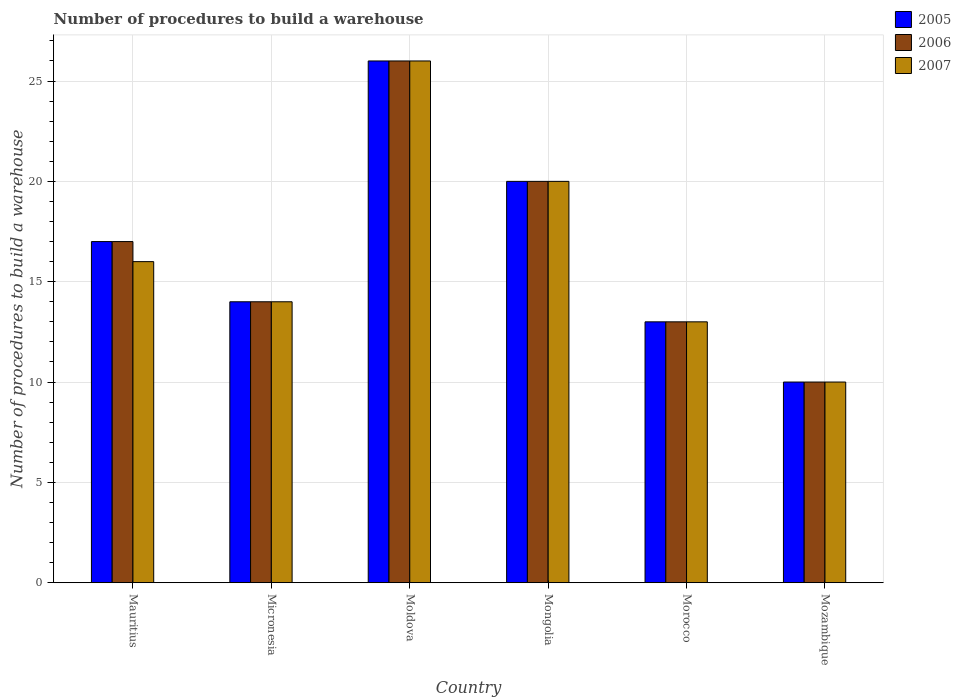How many bars are there on the 6th tick from the right?
Keep it short and to the point. 3. What is the label of the 5th group of bars from the left?
Provide a succinct answer. Morocco. In how many cases, is the number of bars for a given country not equal to the number of legend labels?
Offer a very short reply. 0. Across all countries, what is the maximum number of procedures to build a warehouse in in 2005?
Provide a succinct answer. 26. Across all countries, what is the minimum number of procedures to build a warehouse in in 2005?
Offer a terse response. 10. In which country was the number of procedures to build a warehouse in in 2007 maximum?
Offer a terse response. Moldova. In which country was the number of procedures to build a warehouse in in 2007 minimum?
Your answer should be compact. Mozambique. What is the total number of procedures to build a warehouse in in 2007 in the graph?
Your response must be concise. 99. What is the difference between the number of procedures to build a warehouse in in 2006 in Mongolia and the number of procedures to build a warehouse in in 2007 in Moldova?
Offer a very short reply. -6. What is the average number of procedures to build a warehouse in in 2005 per country?
Your answer should be very brief. 16.67. What is the difference between the number of procedures to build a warehouse in of/in 2007 and number of procedures to build a warehouse in of/in 2005 in Mozambique?
Offer a very short reply. 0. What is the ratio of the number of procedures to build a warehouse in in 2007 in Mauritius to that in Micronesia?
Keep it short and to the point. 1.14. Is the number of procedures to build a warehouse in in 2005 in Micronesia less than that in Mongolia?
Give a very brief answer. Yes. Is the difference between the number of procedures to build a warehouse in in 2007 in Mongolia and Mozambique greater than the difference between the number of procedures to build a warehouse in in 2005 in Mongolia and Mozambique?
Your answer should be compact. No. What is the difference between the highest and the second highest number of procedures to build a warehouse in in 2005?
Give a very brief answer. -9. In how many countries, is the number of procedures to build a warehouse in in 2007 greater than the average number of procedures to build a warehouse in in 2007 taken over all countries?
Offer a very short reply. 2. Is the sum of the number of procedures to build a warehouse in in 2007 in Micronesia and Mongolia greater than the maximum number of procedures to build a warehouse in in 2005 across all countries?
Your answer should be compact. Yes. What does the 1st bar from the left in Mongolia represents?
Your response must be concise. 2005. What does the 2nd bar from the right in Moldova represents?
Keep it short and to the point. 2006. How many bars are there?
Your response must be concise. 18. What is the difference between two consecutive major ticks on the Y-axis?
Ensure brevity in your answer.  5. Are the values on the major ticks of Y-axis written in scientific E-notation?
Your response must be concise. No. Where does the legend appear in the graph?
Offer a terse response. Top right. How many legend labels are there?
Give a very brief answer. 3. What is the title of the graph?
Ensure brevity in your answer.  Number of procedures to build a warehouse. What is the label or title of the X-axis?
Keep it short and to the point. Country. What is the label or title of the Y-axis?
Make the answer very short. Number of procedures to build a warehouse. What is the Number of procedures to build a warehouse in 2005 in Mauritius?
Your answer should be compact. 17. What is the Number of procedures to build a warehouse of 2007 in Mauritius?
Provide a succinct answer. 16. What is the Number of procedures to build a warehouse of 2006 in Moldova?
Your response must be concise. 26. What is the Number of procedures to build a warehouse of 2007 in Moldova?
Your answer should be very brief. 26. What is the Number of procedures to build a warehouse of 2005 in Mongolia?
Your answer should be very brief. 20. What is the Number of procedures to build a warehouse in 2007 in Mongolia?
Provide a short and direct response. 20. What is the Number of procedures to build a warehouse of 2005 in Morocco?
Keep it short and to the point. 13. What is the Number of procedures to build a warehouse in 2007 in Mozambique?
Your answer should be compact. 10. Across all countries, what is the maximum Number of procedures to build a warehouse in 2005?
Your answer should be very brief. 26. Across all countries, what is the minimum Number of procedures to build a warehouse in 2007?
Your response must be concise. 10. What is the total Number of procedures to build a warehouse of 2007 in the graph?
Your answer should be very brief. 99. What is the difference between the Number of procedures to build a warehouse of 2007 in Mauritius and that in Micronesia?
Your answer should be compact. 2. What is the difference between the Number of procedures to build a warehouse in 2006 in Mauritius and that in Moldova?
Offer a terse response. -9. What is the difference between the Number of procedures to build a warehouse in 2007 in Mauritius and that in Moldova?
Provide a succinct answer. -10. What is the difference between the Number of procedures to build a warehouse of 2007 in Mauritius and that in Mongolia?
Offer a terse response. -4. What is the difference between the Number of procedures to build a warehouse in 2006 in Mauritius and that in Morocco?
Your response must be concise. 4. What is the difference between the Number of procedures to build a warehouse of 2007 in Mauritius and that in Morocco?
Give a very brief answer. 3. What is the difference between the Number of procedures to build a warehouse in 2005 in Mauritius and that in Mozambique?
Give a very brief answer. 7. What is the difference between the Number of procedures to build a warehouse of 2006 in Mauritius and that in Mozambique?
Provide a succinct answer. 7. What is the difference between the Number of procedures to build a warehouse of 2007 in Mauritius and that in Mozambique?
Provide a succinct answer. 6. What is the difference between the Number of procedures to build a warehouse of 2005 in Micronesia and that in Moldova?
Give a very brief answer. -12. What is the difference between the Number of procedures to build a warehouse of 2007 in Micronesia and that in Moldova?
Give a very brief answer. -12. What is the difference between the Number of procedures to build a warehouse in 2005 in Micronesia and that in Mongolia?
Provide a succinct answer. -6. What is the difference between the Number of procedures to build a warehouse in 2006 in Micronesia and that in Morocco?
Ensure brevity in your answer.  1. What is the difference between the Number of procedures to build a warehouse of 2005 in Micronesia and that in Mozambique?
Make the answer very short. 4. What is the difference between the Number of procedures to build a warehouse of 2006 in Micronesia and that in Mozambique?
Provide a short and direct response. 4. What is the difference between the Number of procedures to build a warehouse of 2007 in Micronesia and that in Mozambique?
Offer a very short reply. 4. What is the difference between the Number of procedures to build a warehouse of 2005 in Moldova and that in Mongolia?
Your answer should be very brief. 6. What is the difference between the Number of procedures to build a warehouse of 2007 in Moldova and that in Mongolia?
Your answer should be compact. 6. What is the difference between the Number of procedures to build a warehouse in 2005 in Moldova and that in Mozambique?
Ensure brevity in your answer.  16. What is the difference between the Number of procedures to build a warehouse in 2006 in Moldova and that in Mozambique?
Your response must be concise. 16. What is the difference between the Number of procedures to build a warehouse in 2007 in Moldova and that in Mozambique?
Provide a short and direct response. 16. What is the difference between the Number of procedures to build a warehouse in 2007 in Mongolia and that in Morocco?
Provide a short and direct response. 7. What is the difference between the Number of procedures to build a warehouse in 2005 in Mongolia and that in Mozambique?
Make the answer very short. 10. What is the difference between the Number of procedures to build a warehouse of 2006 in Mongolia and that in Mozambique?
Give a very brief answer. 10. What is the difference between the Number of procedures to build a warehouse of 2007 in Mongolia and that in Mozambique?
Your answer should be very brief. 10. What is the difference between the Number of procedures to build a warehouse in 2006 in Morocco and that in Mozambique?
Your response must be concise. 3. What is the difference between the Number of procedures to build a warehouse in 2005 in Mauritius and the Number of procedures to build a warehouse in 2006 in Micronesia?
Ensure brevity in your answer.  3. What is the difference between the Number of procedures to build a warehouse in 2005 in Mauritius and the Number of procedures to build a warehouse in 2007 in Moldova?
Provide a short and direct response. -9. What is the difference between the Number of procedures to build a warehouse of 2006 in Mauritius and the Number of procedures to build a warehouse of 2007 in Moldova?
Offer a very short reply. -9. What is the difference between the Number of procedures to build a warehouse of 2005 in Mauritius and the Number of procedures to build a warehouse of 2006 in Mongolia?
Your answer should be very brief. -3. What is the difference between the Number of procedures to build a warehouse in 2005 in Mauritius and the Number of procedures to build a warehouse in 2007 in Mongolia?
Your response must be concise. -3. What is the difference between the Number of procedures to build a warehouse in 2006 in Mauritius and the Number of procedures to build a warehouse in 2007 in Mongolia?
Your response must be concise. -3. What is the difference between the Number of procedures to build a warehouse of 2005 in Mauritius and the Number of procedures to build a warehouse of 2007 in Mozambique?
Keep it short and to the point. 7. What is the difference between the Number of procedures to build a warehouse of 2006 in Mauritius and the Number of procedures to build a warehouse of 2007 in Mozambique?
Your response must be concise. 7. What is the difference between the Number of procedures to build a warehouse in 2005 in Micronesia and the Number of procedures to build a warehouse in 2006 in Moldova?
Your answer should be compact. -12. What is the difference between the Number of procedures to build a warehouse in 2005 in Micronesia and the Number of procedures to build a warehouse in 2007 in Moldova?
Ensure brevity in your answer.  -12. What is the difference between the Number of procedures to build a warehouse of 2005 in Micronesia and the Number of procedures to build a warehouse of 2007 in Mongolia?
Offer a terse response. -6. What is the difference between the Number of procedures to build a warehouse of 2006 in Micronesia and the Number of procedures to build a warehouse of 2007 in Mongolia?
Your answer should be very brief. -6. What is the difference between the Number of procedures to build a warehouse of 2005 in Micronesia and the Number of procedures to build a warehouse of 2007 in Morocco?
Ensure brevity in your answer.  1. What is the difference between the Number of procedures to build a warehouse of 2006 in Micronesia and the Number of procedures to build a warehouse of 2007 in Morocco?
Ensure brevity in your answer.  1. What is the difference between the Number of procedures to build a warehouse of 2005 in Micronesia and the Number of procedures to build a warehouse of 2006 in Mozambique?
Keep it short and to the point. 4. What is the difference between the Number of procedures to build a warehouse of 2005 in Micronesia and the Number of procedures to build a warehouse of 2007 in Mozambique?
Your answer should be compact. 4. What is the difference between the Number of procedures to build a warehouse in 2006 in Moldova and the Number of procedures to build a warehouse in 2007 in Mongolia?
Provide a short and direct response. 6. What is the difference between the Number of procedures to build a warehouse in 2005 in Moldova and the Number of procedures to build a warehouse in 2006 in Morocco?
Offer a terse response. 13. What is the difference between the Number of procedures to build a warehouse of 2005 in Moldova and the Number of procedures to build a warehouse of 2007 in Morocco?
Keep it short and to the point. 13. What is the difference between the Number of procedures to build a warehouse in 2006 in Moldova and the Number of procedures to build a warehouse in 2007 in Morocco?
Offer a very short reply. 13. What is the difference between the Number of procedures to build a warehouse in 2005 in Moldova and the Number of procedures to build a warehouse in 2007 in Mozambique?
Keep it short and to the point. 16. What is the difference between the Number of procedures to build a warehouse in 2006 in Moldova and the Number of procedures to build a warehouse in 2007 in Mozambique?
Offer a terse response. 16. What is the difference between the Number of procedures to build a warehouse of 2005 in Mongolia and the Number of procedures to build a warehouse of 2007 in Morocco?
Your answer should be compact. 7. What is the difference between the Number of procedures to build a warehouse in 2006 in Mongolia and the Number of procedures to build a warehouse in 2007 in Morocco?
Give a very brief answer. 7. What is the difference between the Number of procedures to build a warehouse in 2005 in Morocco and the Number of procedures to build a warehouse in 2006 in Mozambique?
Your answer should be compact. 3. What is the difference between the Number of procedures to build a warehouse in 2005 in Morocco and the Number of procedures to build a warehouse in 2007 in Mozambique?
Your answer should be compact. 3. What is the average Number of procedures to build a warehouse in 2005 per country?
Your answer should be compact. 16.67. What is the average Number of procedures to build a warehouse of 2006 per country?
Your response must be concise. 16.67. What is the average Number of procedures to build a warehouse in 2007 per country?
Make the answer very short. 16.5. What is the difference between the Number of procedures to build a warehouse in 2005 and Number of procedures to build a warehouse in 2006 in Mauritius?
Provide a succinct answer. 0. What is the difference between the Number of procedures to build a warehouse in 2005 and Number of procedures to build a warehouse in 2006 in Micronesia?
Provide a succinct answer. 0. What is the difference between the Number of procedures to build a warehouse of 2005 and Number of procedures to build a warehouse of 2007 in Micronesia?
Ensure brevity in your answer.  0. What is the difference between the Number of procedures to build a warehouse of 2005 and Number of procedures to build a warehouse of 2006 in Moldova?
Provide a short and direct response. 0. What is the difference between the Number of procedures to build a warehouse in 2005 and Number of procedures to build a warehouse in 2007 in Moldova?
Offer a very short reply. 0. What is the difference between the Number of procedures to build a warehouse in 2005 and Number of procedures to build a warehouse in 2007 in Mongolia?
Your answer should be compact. 0. What is the difference between the Number of procedures to build a warehouse of 2006 and Number of procedures to build a warehouse of 2007 in Mongolia?
Make the answer very short. 0. What is the difference between the Number of procedures to build a warehouse in 2006 and Number of procedures to build a warehouse in 2007 in Morocco?
Your answer should be compact. 0. What is the difference between the Number of procedures to build a warehouse of 2005 and Number of procedures to build a warehouse of 2006 in Mozambique?
Offer a very short reply. 0. What is the difference between the Number of procedures to build a warehouse in 2006 and Number of procedures to build a warehouse in 2007 in Mozambique?
Make the answer very short. 0. What is the ratio of the Number of procedures to build a warehouse of 2005 in Mauritius to that in Micronesia?
Your answer should be very brief. 1.21. What is the ratio of the Number of procedures to build a warehouse in 2006 in Mauritius to that in Micronesia?
Offer a terse response. 1.21. What is the ratio of the Number of procedures to build a warehouse of 2007 in Mauritius to that in Micronesia?
Provide a short and direct response. 1.14. What is the ratio of the Number of procedures to build a warehouse in 2005 in Mauritius to that in Moldova?
Keep it short and to the point. 0.65. What is the ratio of the Number of procedures to build a warehouse of 2006 in Mauritius to that in Moldova?
Your answer should be compact. 0.65. What is the ratio of the Number of procedures to build a warehouse of 2007 in Mauritius to that in Moldova?
Make the answer very short. 0.62. What is the ratio of the Number of procedures to build a warehouse of 2007 in Mauritius to that in Mongolia?
Your answer should be very brief. 0.8. What is the ratio of the Number of procedures to build a warehouse of 2005 in Mauritius to that in Morocco?
Offer a terse response. 1.31. What is the ratio of the Number of procedures to build a warehouse in 2006 in Mauritius to that in Morocco?
Make the answer very short. 1.31. What is the ratio of the Number of procedures to build a warehouse of 2007 in Mauritius to that in Morocco?
Offer a very short reply. 1.23. What is the ratio of the Number of procedures to build a warehouse in 2007 in Mauritius to that in Mozambique?
Give a very brief answer. 1.6. What is the ratio of the Number of procedures to build a warehouse of 2005 in Micronesia to that in Moldova?
Your answer should be compact. 0.54. What is the ratio of the Number of procedures to build a warehouse in 2006 in Micronesia to that in Moldova?
Keep it short and to the point. 0.54. What is the ratio of the Number of procedures to build a warehouse in 2007 in Micronesia to that in Moldova?
Provide a succinct answer. 0.54. What is the ratio of the Number of procedures to build a warehouse in 2006 in Micronesia to that in Mongolia?
Provide a short and direct response. 0.7. What is the ratio of the Number of procedures to build a warehouse in 2007 in Micronesia to that in Mongolia?
Provide a succinct answer. 0.7. What is the ratio of the Number of procedures to build a warehouse of 2005 in Micronesia to that in Morocco?
Your answer should be very brief. 1.08. What is the ratio of the Number of procedures to build a warehouse in 2006 in Micronesia to that in Morocco?
Make the answer very short. 1.08. What is the ratio of the Number of procedures to build a warehouse in 2007 in Micronesia to that in Morocco?
Offer a terse response. 1.08. What is the ratio of the Number of procedures to build a warehouse of 2005 in Moldova to that in Mongolia?
Ensure brevity in your answer.  1.3. What is the ratio of the Number of procedures to build a warehouse of 2006 in Moldova to that in Mongolia?
Your answer should be compact. 1.3. What is the ratio of the Number of procedures to build a warehouse in 2005 in Moldova to that in Morocco?
Provide a succinct answer. 2. What is the ratio of the Number of procedures to build a warehouse in 2005 in Mongolia to that in Morocco?
Your answer should be compact. 1.54. What is the ratio of the Number of procedures to build a warehouse of 2006 in Mongolia to that in Morocco?
Keep it short and to the point. 1.54. What is the ratio of the Number of procedures to build a warehouse in 2007 in Mongolia to that in Morocco?
Ensure brevity in your answer.  1.54. What is the ratio of the Number of procedures to build a warehouse in 2007 in Mongolia to that in Mozambique?
Give a very brief answer. 2. What is the ratio of the Number of procedures to build a warehouse in 2006 in Morocco to that in Mozambique?
Offer a very short reply. 1.3. What is the ratio of the Number of procedures to build a warehouse in 2007 in Morocco to that in Mozambique?
Offer a very short reply. 1.3. What is the difference between the highest and the second highest Number of procedures to build a warehouse in 2006?
Offer a terse response. 6. What is the difference between the highest and the second highest Number of procedures to build a warehouse in 2007?
Give a very brief answer. 6. What is the difference between the highest and the lowest Number of procedures to build a warehouse of 2005?
Your answer should be compact. 16. What is the difference between the highest and the lowest Number of procedures to build a warehouse in 2006?
Your answer should be compact. 16. 